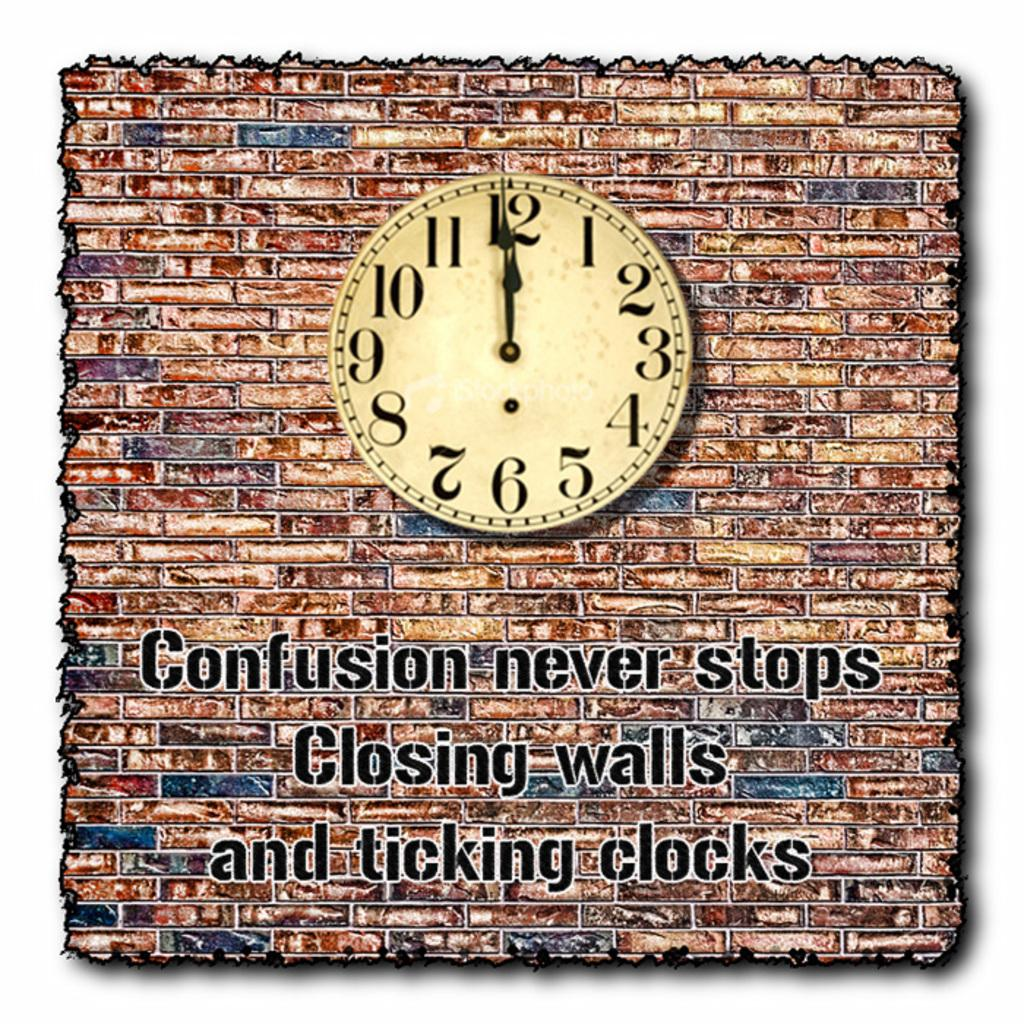<image>
Provide a brief description of the given image. Clock with a brick background and writing that says "Confusion never stops Closing walls and ticking clocks 